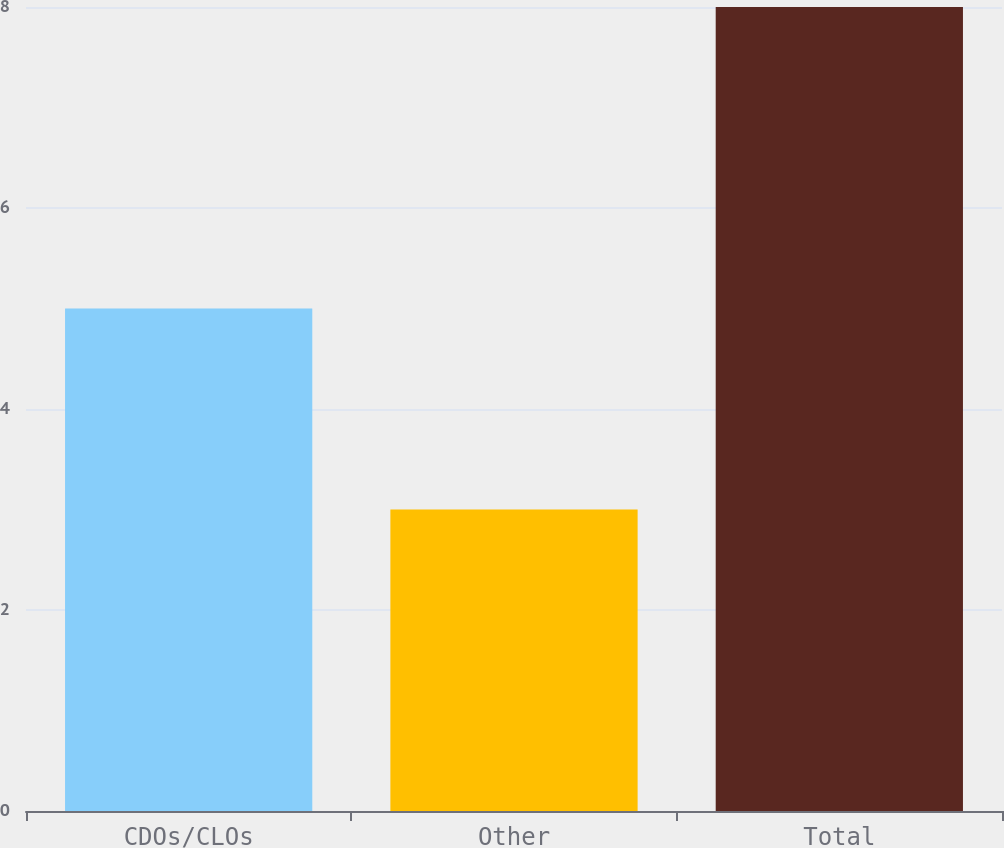Convert chart to OTSL. <chart><loc_0><loc_0><loc_500><loc_500><bar_chart><fcel>CDOs/CLOs<fcel>Other<fcel>Total<nl><fcel>5<fcel>3<fcel>8<nl></chart> 